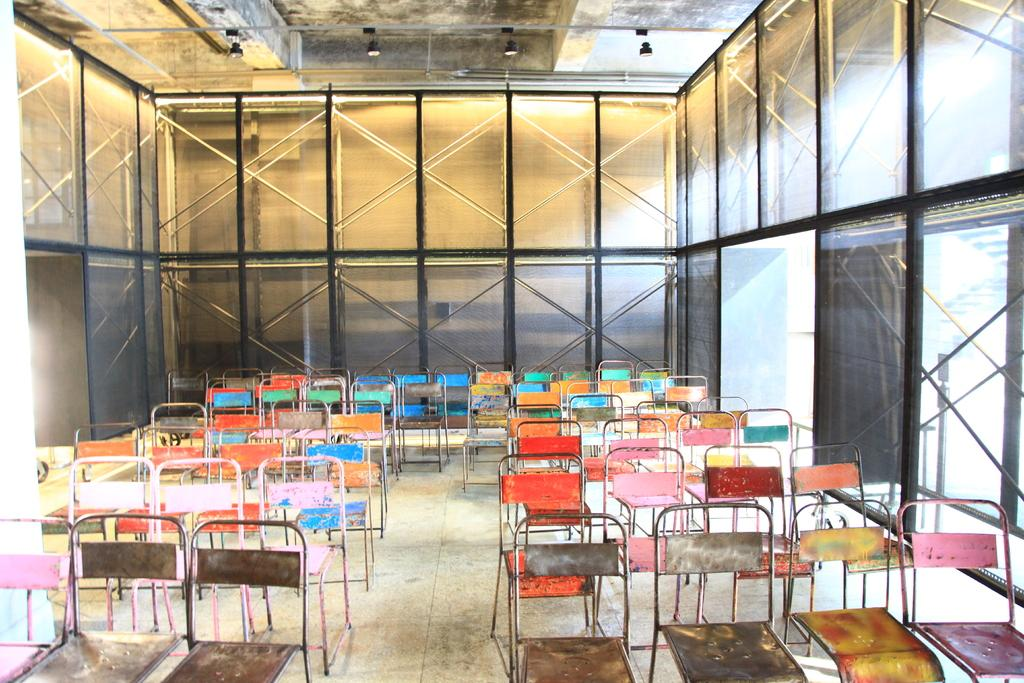What objects are located at the bottom of the image? There is a group of chairs at the bottom of the image. What can be seen in the background of the image? There is a wall, poles, and lights in the background of the image. What type of horse is depicted in the image? There is no horse present in the image. Can you tell me the total cost of the items in the image based on the receipt? There is no receipt present in the image, so it is not possible to determine the total cost of the items. 